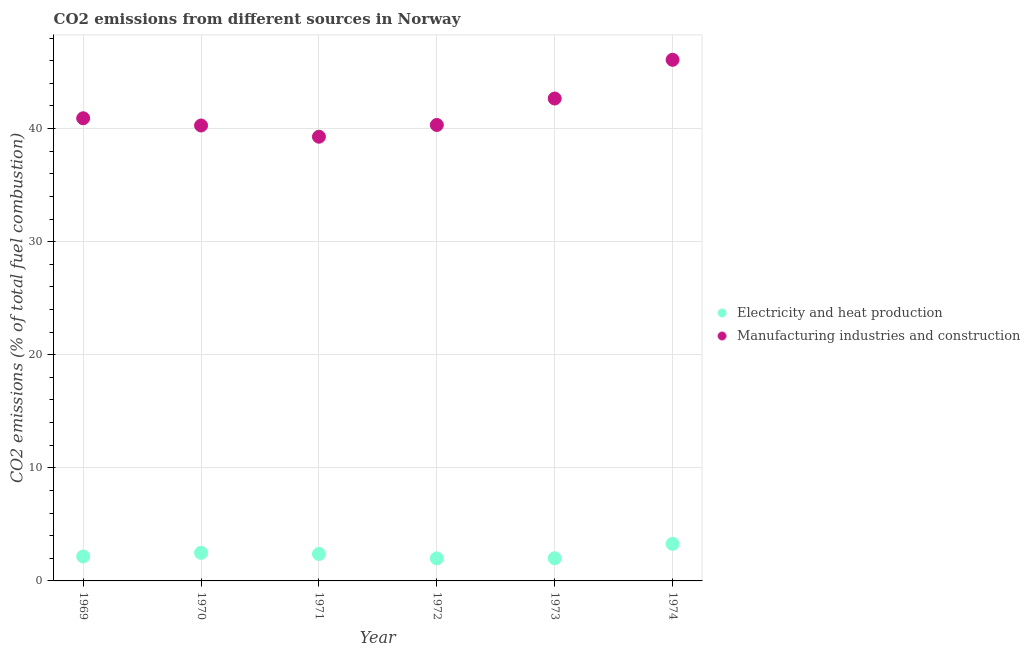Is the number of dotlines equal to the number of legend labels?
Make the answer very short. Yes. What is the co2 emissions due to manufacturing industries in 1969?
Your answer should be compact. 40.91. Across all years, what is the maximum co2 emissions due to electricity and heat production?
Provide a short and direct response. 3.28. Across all years, what is the minimum co2 emissions due to electricity and heat production?
Offer a terse response. 2. In which year was the co2 emissions due to electricity and heat production maximum?
Keep it short and to the point. 1974. In which year was the co2 emissions due to electricity and heat production minimum?
Your answer should be compact. 1972. What is the total co2 emissions due to electricity and heat production in the graph?
Provide a short and direct response. 14.3. What is the difference between the co2 emissions due to manufacturing industries in 1972 and that in 1973?
Give a very brief answer. -2.34. What is the difference between the co2 emissions due to manufacturing industries in 1972 and the co2 emissions due to electricity and heat production in 1969?
Your answer should be compact. 38.16. What is the average co2 emissions due to electricity and heat production per year?
Your answer should be very brief. 2.38. In the year 1970, what is the difference between the co2 emissions due to manufacturing industries and co2 emissions due to electricity and heat production?
Offer a very short reply. 37.79. In how many years, is the co2 emissions due to manufacturing industries greater than 4 %?
Your answer should be compact. 6. What is the ratio of the co2 emissions due to manufacturing industries in 1969 to that in 1972?
Your response must be concise. 1.01. What is the difference between the highest and the second highest co2 emissions due to electricity and heat production?
Offer a terse response. 0.79. What is the difference between the highest and the lowest co2 emissions due to electricity and heat production?
Offer a terse response. 1.28. In how many years, is the co2 emissions due to manufacturing industries greater than the average co2 emissions due to manufacturing industries taken over all years?
Provide a succinct answer. 2. What is the difference between two consecutive major ticks on the Y-axis?
Give a very brief answer. 10. How many legend labels are there?
Your response must be concise. 2. How are the legend labels stacked?
Your response must be concise. Vertical. What is the title of the graph?
Provide a succinct answer. CO2 emissions from different sources in Norway. What is the label or title of the X-axis?
Offer a very short reply. Year. What is the label or title of the Y-axis?
Your response must be concise. CO2 emissions (% of total fuel combustion). What is the CO2 emissions (% of total fuel combustion) of Electricity and heat production in 1969?
Provide a succinct answer. 2.16. What is the CO2 emissions (% of total fuel combustion) in Manufacturing industries and construction in 1969?
Your answer should be compact. 40.91. What is the CO2 emissions (% of total fuel combustion) of Electricity and heat production in 1970?
Your answer should be compact. 2.48. What is the CO2 emissions (% of total fuel combustion) of Manufacturing industries and construction in 1970?
Offer a very short reply. 40.27. What is the CO2 emissions (% of total fuel combustion) in Electricity and heat production in 1971?
Offer a terse response. 2.38. What is the CO2 emissions (% of total fuel combustion) of Manufacturing industries and construction in 1971?
Provide a succinct answer. 39.28. What is the CO2 emissions (% of total fuel combustion) of Electricity and heat production in 1972?
Your response must be concise. 2. What is the CO2 emissions (% of total fuel combustion) in Manufacturing industries and construction in 1972?
Provide a short and direct response. 40.32. What is the CO2 emissions (% of total fuel combustion) in Electricity and heat production in 1973?
Your response must be concise. 2. What is the CO2 emissions (% of total fuel combustion) in Manufacturing industries and construction in 1973?
Provide a short and direct response. 42.65. What is the CO2 emissions (% of total fuel combustion) in Electricity and heat production in 1974?
Provide a short and direct response. 3.28. What is the CO2 emissions (% of total fuel combustion) in Manufacturing industries and construction in 1974?
Your response must be concise. 46.08. Across all years, what is the maximum CO2 emissions (% of total fuel combustion) of Electricity and heat production?
Your answer should be very brief. 3.28. Across all years, what is the maximum CO2 emissions (% of total fuel combustion) of Manufacturing industries and construction?
Ensure brevity in your answer.  46.08. Across all years, what is the minimum CO2 emissions (% of total fuel combustion) of Electricity and heat production?
Your answer should be compact. 2. Across all years, what is the minimum CO2 emissions (% of total fuel combustion) of Manufacturing industries and construction?
Offer a terse response. 39.28. What is the total CO2 emissions (% of total fuel combustion) in Electricity and heat production in the graph?
Ensure brevity in your answer.  14.3. What is the total CO2 emissions (% of total fuel combustion) in Manufacturing industries and construction in the graph?
Give a very brief answer. 249.5. What is the difference between the CO2 emissions (% of total fuel combustion) of Electricity and heat production in 1969 and that in 1970?
Make the answer very short. -0.32. What is the difference between the CO2 emissions (% of total fuel combustion) of Manufacturing industries and construction in 1969 and that in 1970?
Ensure brevity in your answer.  0.64. What is the difference between the CO2 emissions (% of total fuel combustion) in Electricity and heat production in 1969 and that in 1971?
Provide a short and direct response. -0.22. What is the difference between the CO2 emissions (% of total fuel combustion) in Manufacturing industries and construction in 1969 and that in 1971?
Your response must be concise. 1.63. What is the difference between the CO2 emissions (% of total fuel combustion) in Electricity and heat production in 1969 and that in 1972?
Provide a short and direct response. 0.17. What is the difference between the CO2 emissions (% of total fuel combustion) of Manufacturing industries and construction in 1969 and that in 1972?
Provide a short and direct response. 0.59. What is the difference between the CO2 emissions (% of total fuel combustion) of Electricity and heat production in 1969 and that in 1973?
Your response must be concise. 0.16. What is the difference between the CO2 emissions (% of total fuel combustion) of Manufacturing industries and construction in 1969 and that in 1973?
Provide a succinct answer. -1.75. What is the difference between the CO2 emissions (% of total fuel combustion) in Electricity and heat production in 1969 and that in 1974?
Provide a short and direct response. -1.12. What is the difference between the CO2 emissions (% of total fuel combustion) in Manufacturing industries and construction in 1969 and that in 1974?
Your answer should be compact. -5.17. What is the difference between the CO2 emissions (% of total fuel combustion) in Electricity and heat production in 1970 and that in 1971?
Provide a short and direct response. 0.1. What is the difference between the CO2 emissions (% of total fuel combustion) of Manufacturing industries and construction in 1970 and that in 1971?
Ensure brevity in your answer.  0.99. What is the difference between the CO2 emissions (% of total fuel combustion) of Electricity and heat production in 1970 and that in 1972?
Give a very brief answer. 0.49. What is the difference between the CO2 emissions (% of total fuel combustion) of Manufacturing industries and construction in 1970 and that in 1972?
Your response must be concise. -0.05. What is the difference between the CO2 emissions (% of total fuel combustion) of Electricity and heat production in 1970 and that in 1973?
Offer a terse response. 0.48. What is the difference between the CO2 emissions (% of total fuel combustion) of Manufacturing industries and construction in 1970 and that in 1973?
Your response must be concise. -2.39. What is the difference between the CO2 emissions (% of total fuel combustion) in Electricity and heat production in 1970 and that in 1974?
Your answer should be compact. -0.79. What is the difference between the CO2 emissions (% of total fuel combustion) in Manufacturing industries and construction in 1970 and that in 1974?
Give a very brief answer. -5.81. What is the difference between the CO2 emissions (% of total fuel combustion) in Electricity and heat production in 1971 and that in 1972?
Provide a short and direct response. 0.39. What is the difference between the CO2 emissions (% of total fuel combustion) in Manufacturing industries and construction in 1971 and that in 1972?
Offer a very short reply. -1.04. What is the difference between the CO2 emissions (% of total fuel combustion) of Electricity and heat production in 1971 and that in 1973?
Provide a succinct answer. 0.38. What is the difference between the CO2 emissions (% of total fuel combustion) in Manufacturing industries and construction in 1971 and that in 1973?
Keep it short and to the point. -3.38. What is the difference between the CO2 emissions (% of total fuel combustion) in Electricity and heat production in 1971 and that in 1974?
Your answer should be compact. -0.89. What is the difference between the CO2 emissions (% of total fuel combustion) in Manufacturing industries and construction in 1971 and that in 1974?
Offer a very short reply. -6.8. What is the difference between the CO2 emissions (% of total fuel combustion) in Electricity and heat production in 1972 and that in 1973?
Provide a short and direct response. -0.01. What is the difference between the CO2 emissions (% of total fuel combustion) of Manufacturing industries and construction in 1972 and that in 1973?
Give a very brief answer. -2.34. What is the difference between the CO2 emissions (% of total fuel combustion) in Electricity and heat production in 1972 and that in 1974?
Provide a succinct answer. -1.28. What is the difference between the CO2 emissions (% of total fuel combustion) of Manufacturing industries and construction in 1972 and that in 1974?
Offer a terse response. -5.76. What is the difference between the CO2 emissions (% of total fuel combustion) in Electricity and heat production in 1973 and that in 1974?
Your answer should be compact. -1.27. What is the difference between the CO2 emissions (% of total fuel combustion) of Manufacturing industries and construction in 1973 and that in 1974?
Provide a succinct answer. -3.42. What is the difference between the CO2 emissions (% of total fuel combustion) of Electricity and heat production in 1969 and the CO2 emissions (% of total fuel combustion) of Manufacturing industries and construction in 1970?
Offer a very short reply. -38.11. What is the difference between the CO2 emissions (% of total fuel combustion) of Electricity and heat production in 1969 and the CO2 emissions (% of total fuel combustion) of Manufacturing industries and construction in 1971?
Offer a very short reply. -37.12. What is the difference between the CO2 emissions (% of total fuel combustion) in Electricity and heat production in 1969 and the CO2 emissions (% of total fuel combustion) in Manufacturing industries and construction in 1972?
Make the answer very short. -38.16. What is the difference between the CO2 emissions (% of total fuel combustion) of Electricity and heat production in 1969 and the CO2 emissions (% of total fuel combustion) of Manufacturing industries and construction in 1973?
Offer a very short reply. -40.49. What is the difference between the CO2 emissions (% of total fuel combustion) in Electricity and heat production in 1969 and the CO2 emissions (% of total fuel combustion) in Manufacturing industries and construction in 1974?
Give a very brief answer. -43.92. What is the difference between the CO2 emissions (% of total fuel combustion) in Electricity and heat production in 1970 and the CO2 emissions (% of total fuel combustion) in Manufacturing industries and construction in 1971?
Your answer should be compact. -36.79. What is the difference between the CO2 emissions (% of total fuel combustion) in Electricity and heat production in 1970 and the CO2 emissions (% of total fuel combustion) in Manufacturing industries and construction in 1972?
Ensure brevity in your answer.  -37.83. What is the difference between the CO2 emissions (% of total fuel combustion) in Electricity and heat production in 1970 and the CO2 emissions (% of total fuel combustion) in Manufacturing industries and construction in 1973?
Keep it short and to the point. -40.17. What is the difference between the CO2 emissions (% of total fuel combustion) of Electricity and heat production in 1970 and the CO2 emissions (% of total fuel combustion) of Manufacturing industries and construction in 1974?
Make the answer very short. -43.59. What is the difference between the CO2 emissions (% of total fuel combustion) in Electricity and heat production in 1971 and the CO2 emissions (% of total fuel combustion) in Manufacturing industries and construction in 1972?
Make the answer very short. -37.93. What is the difference between the CO2 emissions (% of total fuel combustion) of Electricity and heat production in 1971 and the CO2 emissions (% of total fuel combustion) of Manufacturing industries and construction in 1973?
Ensure brevity in your answer.  -40.27. What is the difference between the CO2 emissions (% of total fuel combustion) in Electricity and heat production in 1971 and the CO2 emissions (% of total fuel combustion) in Manufacturing industries and construction in 1974?
Offer a very short reply. -43.69. What is the difference between the CO2 emissions (% of total fuel combustion) in Electricity and heat production in 1972 and the CO2 emissions (% of total fuel combustion) in Manufacturing industries and construction in 1973?
Provide a succinct answer. -40.66. What is the difference between the CO2 emissions (% of total fuel combustion) of Electricity and heat production in 1972 and the CO2 emissions (% of total fuel combustion) of Manufacturing industries and construction in 1974?
Provide a short and direct response. -44.08. What is the difference between the CO2 emissions (% of total fuel combustion) of Electricity and heat production in 1973 and the CO2 emissions (% of total fuel combustion) of Manufacturing industries and construction in 1974?
Ensure brevity in your answer.  -44.07. What is the average CO2 emissions (% of total fuel combustion) in Electricity and heat production per year?
Provide a succinct answer. 2.38. What is the average CO2 emissions (% of total fuel combustion) in Manufacturing industries and construction per year?
Your answer should be compact. 41.58. In the year 1969, what is the difference between the CO2 emissions (% of total fuel combustion) of Electricity and heat production and CO2 emissions (% of total fuel combustion) of Manufacturing industries and construction?
Your response must be concise. -38.75. In the year 1970, what is the difference between the CO2 emissions (% of total fuel combustion) of Electricity and heat production and CO2 emissions (% of total fuel combustion) of Manufacturing industries and construction?
Ensure brevity in your answer.  -37.78. In the year 1971, what is the difference between the CO2 emissions (% of total fuel combustion) in Electricity and heat production and CO2 emissions (% of total fuel combustion) in Manufacturing industries and construction?
Your answer should be compact. -36.89. In the year 1972, what is the difference between the CO2 emissions (% of total fuel combustion) of Electricity and heat production and CO2 emissions (% of total fuel combustion) of Manufacturing industries and construction?
Make the answer very short. -38.32. In the year 1973, what is the difference between the CO2 emissions (% of total fuel combustion) in Electricity and heat production and CO2 emissions (% of total fuel combustion) in Manufacturing industries and construction?
Ensure brevity in your answer.  -40.65. In the year 1974, what is the difference between the CO2 emissions (% of total fuel combustion) of Electricity and heat production and CO2 emissions (% of total fuel combustion) of Manufacturing industries and construction?
Provide a short and direct response. -42.8. What is the ratio of the CO2 emissions (% of total fuel combustion) of Electricity and heat production in 1969 to that in 1970?
Provide a succinct answer. 0.87. What is the ratio of the CO2 emissions (% of total fuel combustion) of Manufacturing industries and construction in 1969 to that in 1970?
Ensure brevity in your answer.  1.02. What is the ratio of the CO2 emissions (% of total fuel combustion) in Electricity and heat production in 1969 to that in 1971?
Provide a short and direct response. 0.91. What is the ratio of the CO2 emissions (% of total fuel combustion) in Manufacturing industries and construction in 1969 to that in 1971?
Provide a short and direct response. 1.04. What is the ratio of the CO2 emissions (% of total fuel combustion) in Electricity and heat production in 1969 to that in 1972?
Make the answer very short. 1.08. What is the ratio of the CO2 emissions (% of total fuel combustion) in Manufacturing industries and construction in 1969 to that in 1972?
Your answer should be very brief. 1.01. What is the ratio of the CO2 emissions (% of total fuel combustion) in Electricity and heat production in 1969 to that in 1973?
Ensure brevity in your answer.  1.08. What is the ratio of the CO2 emissions (% of total fuel combustion) of Manufacturing industries and construction in 1969 to that in 1973?
Ensure brevity in your answer.  0.96. What is the ratio of the CO2 emissions (% of total fuel combustion) of Electricity and heat production in 1969 to that in 1974?
Keep it short and to the point. 0.66. What is the ratio of the CO2 emissions (% of total fuel combustion) of Manufacturing industries and construction in 1969 to that in 1974?
Make the answer very short. 0.89. What is the ratio of the CO2 emissions (% of total fuel combustion) of Electricity and heat production in 1970 to that in 1971?
Ensure brevity in your answer.  1.04. What is the ratio of the CO2 emissions (% of total fuel combustion) in Manufacturing industries and construction in 1970 to that in 1971?
Your answer should be compact. 1.03. What is the ratio of the CO2 emissions (% of total fuel combustion) in Electricity and heat production in 1970 to that in 1972?
Offer a terse response. 1.25. What is the ratio of the CO2 emissions (% of total fuel combustion) in Electricity and heat production in 1970 to that in 1973?
Your answer should be compact. 1.24. What is the ratio of the CO2 emissions (% of total fuel combustion) in Manufacturing industries and construction in 1970 to that in 1973?
Your response must be concise. 0.94. What is the ratio of the CO2 emissions (% of total fuel combustion) in Electricity and heat production in 1970 to that in 1974?
Your answer should be compact. 0.76. What is the ratio of the CO2 emissions (% of total fuel combustion) of Manufacturing industries and construction in 1970 to that in 1974?
Offer a very short reply. 0.87. What is the ratio of the CO2 emissions (% of total fuel combustion) in Electricity and heat production in 1971 to that in 1972?
Keep it short and to the point. 1.19. What is the ratio of the CO2 emissions (% of total fuel combustion) of Manufacturing industries and construction in 1971 to that in 1972?
Your answer should be very brief. 0.97. What is the ratio of the CO2 emissions (% of total fuel combustion) in Electricity and heat production in 1971 to that in 1973?
Give a very brief answer. 1.19. What is the ratio of the CO2 emissions (% of total fuel combustion) of Manufacturing industries and construction in 1971 to that in 1973?
Your response must be concise. 0.92. What is the ratio of the CO2 emissions (% of total fuel combustion) of Electricity and heat production in 1971 to that in 1974?
Keep it short and to the point. 0.73. What is the ratio of the CO2 emissions (% of total fuel combustion) of Manufacturing industries and construction in 1971 to that in 1974?
Provide a short and direct response. 0.85. What is the ratio of the CO2 emissions (% of total fuel combustion) of Manufacturing industries and construction in 1972 to that in 1973?
Your answer should be very brief. 0.95. What is the ratio of the CO2 emissions (% of total fuel combustion) in Electricity and heat production in 1972 to that in 1974?
Offer a terse response. 0.61. What is the ratio of the CO2 emissions (% of total fuel combustion) in Manufacturing industries and construction in 1972 to that in 1974?
Keep it short and to the point. 0.88. What is the ratio of the CO2 emissions (% of total fuel combustion) of Electricity and heat production in 1973 to that in 1974?
Make the answer very short. 0.61. What is the ratio of the CO2 emissions (% of total fuel combustion) of Manufacturing industries and construction in 1973 to that in 1974?
Your answer should be compact. 0.93. What is the difference between the highest and the second highest CO2 emissions (% of total fuel combustion) in Electricity and heat production?
Keep it short and to the point. 0.79. What is the difference between the highest and the second highest CO2 emissions (% of total fuel combustion) of Manufacturing industries and construction?
Keep it short and to the point. 3.42. What is the difference between the highest and the lowest CO2 emissions (% of total fuel combustion) in Electricity and heat production?
Your answer should be very brief. 1.28. What is the difference between the highest and the lowest CO2 emissions (% of total fuel combustion) of Manufacturing industries and construction?
Your answer should be compact. 6.8. 